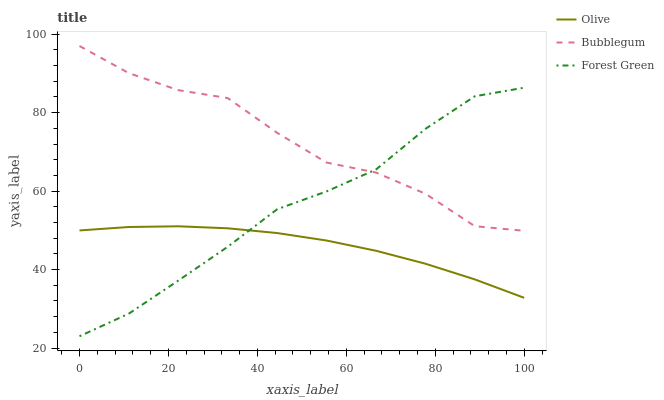Does Olive have the minimum area under the curve?
Answer yes or no. Yes. Does Bubblegum have the maximum area under the curve?
Answer yes or no. Yes. Does Forest Green have the minimum area under the curve?
Answer yes or no. No. Does Forest Green have the maximum area under the curve?
Answer yes or no. No. Is Olive the smoothest?
Answer yes or no. Yes. Is Bubblegum the roughest?
Answer yes or no. Yes. Is Forest Green the smoothest?
Answer yes or no. No. Is Forest Green the roughest?
Answer yes or no. No. Does Forest Green have the lowest value?
Answer yes or no. Yes. Does Bubblegum have the lowest value?
Answer yes or no. No. Does Bubblegum have the highest value?
Answer yes or no. Yes. Does Forest Green have the highest value?
Answer yes or no. No. Is Olive less than Bubblegum?
Answer yes or no. Yes. Is Bubblegum greater than Olive?
Answer yes or no. Yes. Does Forest Green intersect Bubblegum?
Answer yes or no. Yes. Is Forest Green less than Bubblegum?
Answer yes or no. No. Is Forest Green greater than Bubblegum?
Answer yes or no. No. Does Olive intersect Bubblegum?
Answer yes or no. No. 